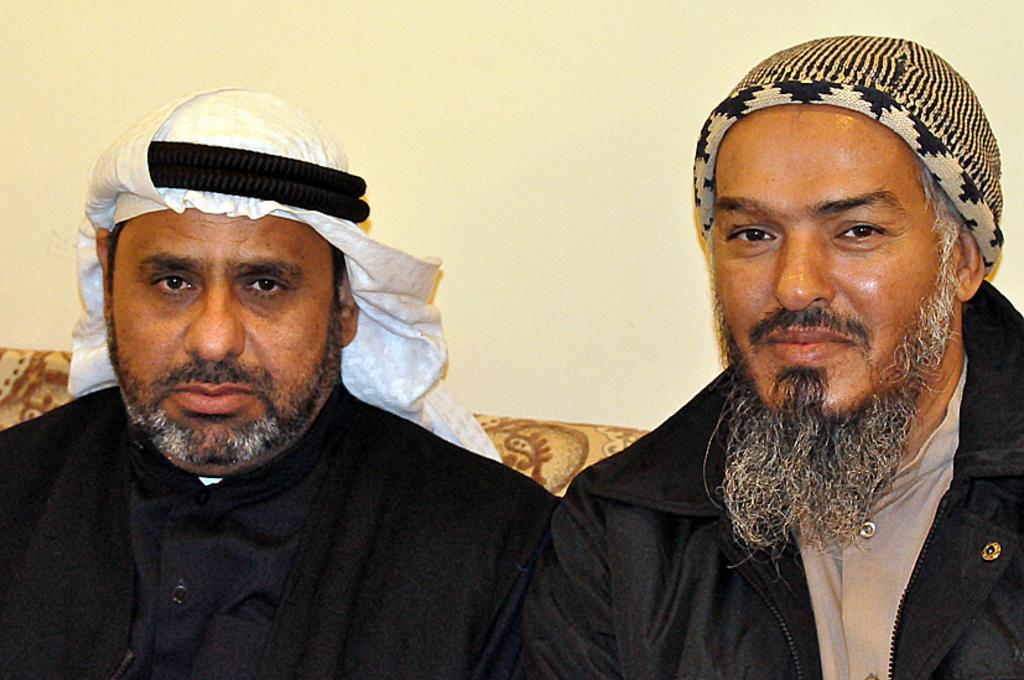How many people are in the image? There are two men in the image. What are the men doing in the image? The men are sitting on a sofa and smiling. What can be seen in the background of the image? There is a wall in the background of the image. What type of pump is visible in the image? There is no pump present in the image. What is the view from the top of the sofa in the image? The image does not provide a view from the top of the sofa, as it only shows the two men sitting on it. 